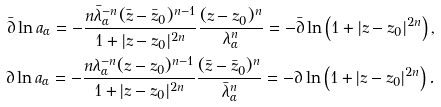Convert formula to latex. <formula><loc_0><loc_0><loc_500><loc_500>\bar { \partial } \ln a _ { \alpha } = - \frac { n \bar { \lambda } ^ { - n } _ { \alpha } ( \bar { z } - \bar { z } _ { 0 } ) ^ { n - 1 } } { 1 + | z - z _ { 0 } | ^ { 2 n } } \frac { ( z - z _ { 0 } ) ^ { n } } { \lambda _ { \alpha } ^ { n } } = - \bar { \partial } \ln \left ( 1 + | z - z _ { 0 } | ^ { 2 n } \right ) , \\ \partial \ln a _ { \alpha } = - \frac { n \lambda ^ { - n } _ { \alpha } ( z - z _ { 0 } ) ^ { n - 1 } } { 1 + | z - z _ { 0 } | ^ { 2 n } } \frac { ( \bar { z } - \bar { z } _ { 0 } ) ^ { n } } { \bar { \lambda } _ { \alpha } ^ { n } } = - \partial \ln \left ( 1 + | z - z _ { 0 } | ^ { 2 n } \right ) .</formula> 